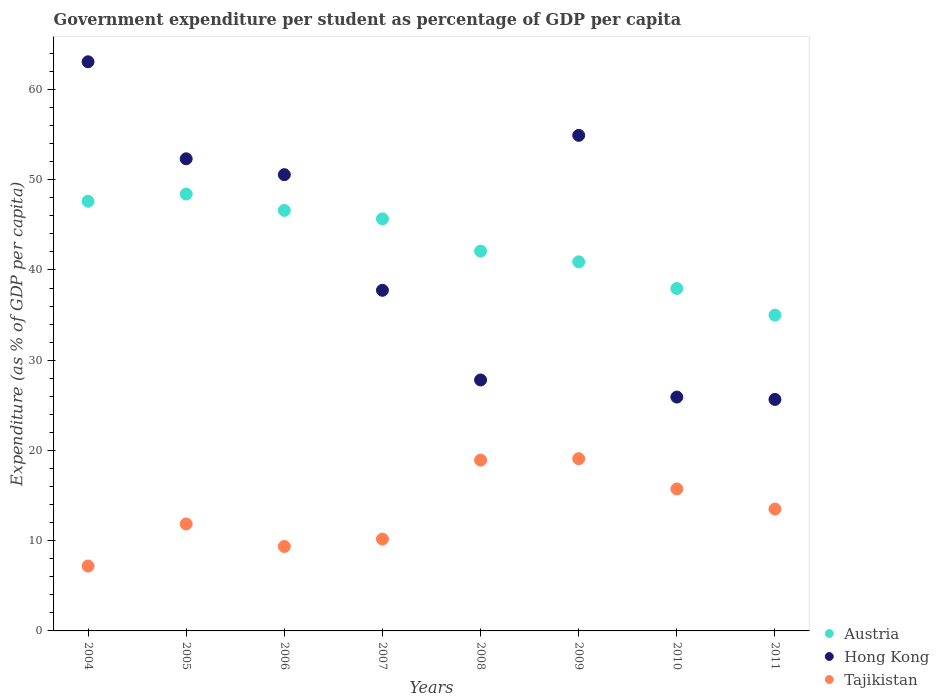What is the percentage of expenditure per student in Austria in 2006?
Your answer should be compact. 46.61. Across all years, what is the maximum percentage of expenditure per student in Austria?
Your answer should be compact. 48.42. Across all years, what is the minimum percentage of expenditure per student in Austria?
Keep it short and to the point. 35. In which year was the percentage of expenditure per student in Austria maximum?
Your response must be concise. 2005. What is the total percentage of expenditure per student in Tajikistan in the graph?
Make the answer very short. 105.85. What is the difference between the percentage of expenditure per student in Austria in 2006 and that in 2009?
Give a very brief answer. 5.7. What is the difference between the percentage of expenditure per student in Hong Kong in 2005 and the percentage of expenditure per student in Austria in 2008?
Provide a succinct answer. 10.23. What is the average percentage of expenditure per student in Tajikistan per year?
Offer a terse response. 13.23. In the year 2010, what is the difference between the percentage of expenditure per student in Hong Kong and percentage of expenditure per student in Tajikistan?
Provide a short and direct response. 10.18. In how many years, is the percentage of expenditure per student in Tajikistan greater than 46 %?
Offer a very short reply. 0. What is the ratio of the percentage of expenditure per student in Austria in 2006 to that in 2008?
Provide a succinct answer. 1.11. Is the percentage of expenditure per student in Tajikistan in 2006 less than that in 2011?
Provide a short and direct response. Yes. Is the difference between the percentage of expenditure per student in Hong Kong in 2007 and 2011 greater than the difference between the percentage of expenditure per student in Tajikistan in 2007 and 2011?
Ensure brevity in your answer.  Yes. What is the difference between the highest and the second highest percentage of expenditure per student in Tajikistan?
Offer a very short reply. 0.15. What is the difference between the highest and the lowest percentage of expenditure per student in Austria?
Provide a succinct answer. 13.42. In how many years, is the percentage of expenditure per student in Austria greater than the average percentage of expenditure per student in Austria taken over all years?
Your answer should be very brief. 4. Does the percentage of expenditure per student in Austria monotonically increase over the years?
Provide a short and direct response. No. Is the percentage of expenditure per student in Austria strictly greater than the percentage of expenditure per student in Tajikistan over the years?
Your answer should be compact. Yes. How many dotlines are there?
Your response must be concise. 3. Does the graph contain grids?
Your answer should be compact. No. How many legend labels are there?
Your answer should be compact. 3. How are the legend labels stacked?
Keep it short and to the point. Vertical. What is the title of the graph?
Keep it short and to the point. Government expenditure per student as percentage of GDP per capita. Does "Kenya" appear as one of the legend labels in the graph?
Give a very brief answer. No. What is the label or title of the X-axis?
Your answer should be very brief. Years. What is the label or title of the Y-axis?
Your answer should be very brief. Expenditure (as % of GDP per capita). What is the Expenditure (as % of GDP per capita) in Austria in 2004?
Give a very brief answer. 47.62. What is the Expenditure (as % of GDP per capita) of Hong Kong in 2004?
Ensure brevity in your answer.  63.07. What is the Expenditure (as % of GDP per capita) of Tajikistan in 2004?
Provide a short and direct response. 7.19. What is the Expenditure (as % of GDP per capita) of Austria in 2005?
Offer a very short reply. 48.42. What is the Expenditure (as % of GDP per capita) in Hong Kong in 2005?
Your response must be concise. 52.32. What is the Expenditure (as % of GDP per capita) in Tajikistan in 2005?
Keep it short and to the point. 11.86. What is the Expenditure (as % of GDP per capita) in Austria in 2006?
Provide a succinct answer. 46.61. What is the Expenditure (as % of GDP per capita) in Hong Kong in 2006?
Give a very brief answer. 50.56. What is the Expenditure (as % of GDP per capita) of Tajikistan in 2006?
Your answer should be compact. 9.36. What is the Expenditure (as % of GDP per capita) of Austria in 2007?
Your answer should be very brief. 45.67. What is the Expenditure (as % of GDP per capita) in Hong Kong in 2007?
Your answer should be compact. 37.75. What is the Expenditure (as % of GDP per capita) of Tajikistan in 2007?
Your answer should be compact. 10.18. What is the Expenditure (as % of GDP per capita) in Austria in 2008?
Make the answer very short. 42.09. What is the Expenditure (as % of GDP per capita) in Hong Kong in 2008?
Your answer should be very brief. 27.81. What is the Expenditure (as % of GDP per capita) of Tajikistan in 2008?
Your response must be concise. 18.93. What is the Expenditure (as % of GDP per capita) in Austria in 2009?
Your answer should be compact. 40.91. What is the Expenditure (as % of GDP per capita) of Hong Kong in 2009?
Ensure brevity in your answer.  54.92. What is the Expenditure (as % of GDP per capita) of Tajikistan in 2009?
Your response must be concise. 19.09. What is the Expenditure (as % of GDP per capita) in Austria in 2010?
Give a very brief answer. 37.95. What is the Expenditure (as % of GDP per capita) in Hong Kong in 2010?
Your answer should be very brief. 25.92. What is the Expenditure (as % of GDP per capita) in Tajikistan in 2010?
Your answer should be very brief. 15.73. What is the Expenditure (as % of GDP per capita) of Austria in 2011?
Your answer should be compact. 35. What is the Expenditure (as % of GDP per capita) in Hong Kong in 2011?
Your answer should be very brief. 25.65. What is the Expenditure (as % of GDP per capita) in Tajikistan in 2011?
Ensure brevity in your answer.  13.51. Across all years, what is the maximum Expenditure (as % of GDP per capita) of Austria?
Your answer should be very brief. 48.42. Across all years, what is the maximum Expenditure (as % of GDP per capita) in Hong Kong?
Provide a short and direct response. 63.07. Across all years, what is the maximum Expenditure (as % of GDP per capita) in Tajikistan?
Keep it short and to the point. 19.09. Across all years, what is the minimum Expenditure (as % of GDP per capita) of Austria?
Provide a short and direct response. 35. Across all years, what is the minimum Expenditure (as % of GDP per capita) of Hong Kong?
Keep it short and to the point. 25.65. Across all years, what is the minimum Expenditure (as % of GDP per capita) of Tajikistan?
Give a very brief answer. 7.19. What is the total Expenditure (as % of GDP per capita) in Austria in the graph?
Offer a very short reply. 344.25. What is the total Expenditure (as % of GDP per capita) of Hong Kong in the graph?
Keep it short and to the point. 338.02. What is the total Expenditure (as % of GDP per capita) in Tajikistan in the graph?
Provide a succinct answer. 105.85. What is the difference between the Expenditure (as % of GDP per capita) in Austria in 2004 and that in 2005?
Provide a succinct answer. -0.8. What is the difference between the Expenditure (as % of GDP per capita) in Hong Kong in 2004 and that in 2005?
Your answer should be very brief. 10.75. What is the difference between the Expenditure (as % of GDP per capita) in Tajikistan in 2004 and that in 2005?
Make the answer very short. -4.67. What is the difference between the Expenditure (as % of GDP per capita) in Austria in 2004 and that in 2006?
Offer a very short reply. 1.01. What is the difference between the Expenditure (as % of GDP per capita) in Hong Kong in 2004 and that in 2006?
Offer a terse response. 12.51. What is the difference between the Expenditure (as % of GDP per capita) of Tajikistan in 2004 and that in 2006?
Give a very brief answer. -2.17. What is the difference between the Expenditure (as % of GDP per capita) in Austria in 2004 and that in 2007?
Ensure brevity in your answer.  1.95. What is the difference between the Expenditure (as % of GDP per capita) of Hong Kong in 2004 and that in 2007?
Provide a short and direct response. 25.32. What is the difference between the Expenditure (as % of GDP per capita) of Tajikistan in 2004 and that in 2007?
Offer a very short reply. -2.98. What is the difference between the Expenditure (as % of GDP per capita) in Austria in 2004 and that in 2008?
Offer a very short reply. 5.53. What is the difference between the Expenditure (as % of GDP per capita) of Hong Kong in 2004 and that in 2008?
Your answer should be very brief. 35.26. What is the difference between the Expenditure (as % of GDP per capita) in Tajikistan in 2004 and that in 2008?
Your answer should be compact. -11.74. What is the difference between the Expenditure (as % of GDP per capita) in Austria in 2004 and that in 2009?
Your response must be concise. 6.71. What is the difference between the Expenditure (as % of GDP per capita) in Hong Kong in 2004 and that in 2009?
Keep it short and to the point. 8.15. What is the difference between the Expenditure (as % of GDP per capita) in Tajikistan in 2004 and that in 2009?
Offer a terse response. -11.89. What is the difference between the Expenditure (as % of GDP per capita) in Austria in 2004 and that in 2010?
Your response must be concise. 9.67. What is the difference between the Expenditure (as % of GDP per capita) of Hong Kong in 2004 and that in 2010?
Offer a terse response. 37.16. What is the difference between the Expenditure (as % of GDP per capita) of Tajikistan in 2004 and that in 2010?
Keep it short and to the point. -8.54. What is the difference between the Expenditure (as % of GDP per capita) in Austria in 2004 and that in 2011?
Offer a very short reply. 12.62. What is the difference between the Expenditure (as % of GDP per capita) of Hong Kong in 2004 and that in 2011?
Offer a very short reply. 37.42. What is the difference between the Expenditure (as % of GDP per capita) in Tajikistan in 2004 and that in 2011?
Make the answer very short. -6.31. What is the difference between the Expenditure (as % of GDP per capita) of Austria in 2005 and that in 2006?
Offer a very short reply. 1.81. What is the difference between the Expenditure (as % of GDP per capita) of Hong Kong in 2005 and that in 2006?
Make the answer very short. 1.76. What is the difference between the Expenditure (as % of GDP per capita) of Tajikistan in 2005 and that in 2006?
Your answer should be compact. 2.5. What is the difference between the Expenditure (as % of GDP per capita) of Austria in 2005 and that in 2007?
Provide a succinct answer. 2.75. What is the difference between the Expenditure (as % of GDP per capita) of Hong Kong in 2005 and that in 2007?
Make the answer very short. 14.57. What is the difference between the Expenditure (as % of GDP per capita) in Tajikistan in 2005 and that in 2007?
Ensure brevity in your answer.  1.68. What is the difference between the Expenditure (as % of GDP per capita) of Austria in 2005 and that in 2008?
Your answer should be compact. 6.33. What is the difference between the Expenditure (as % of GDP per capita) in Hong Kong in 2005 and that in 2008?
Give a very brief answer. 24.51. What is the difference between the Expenditure (as % of GDP per capita) in Tajikistan in 2005 and that in 2008?
Offer a very short reply. -7.07. What is the difference between the Expenditure (as % of GDP per capita) in Austria in 2005 and that in 2009?
Offer a terse response. 7.51. What is the difference between the Expenditure (as % of GDP per capita) in Hong Kong in 2005 and that in 2009?
Make the answer very short. -2.6. What is the difference between the Expenditure (as % of GDP per capita) of Tajikistan in 2005 and that in 2009?
Your response must be concise. -7.23. What is the difference between the Expenditure (as % of GDP per capita) of Austria in 2005 and that in 2010?
Ensure brevity in your answer.  10.47. What is the difference between the Expenditure (as % of GDP per capita) in Hong Kong in 2005 and that in 2010?
Provide a succinct answer. 26.4. What is the difference between the Expenditure (as % of GDP per capita) of Tajikistan in 2005 and that in 2010?
Keep it short and to the point. -3.88. What is the difference between the Expenditure (as % of GDP per capita) in Austria in 2005 and that in 2011?
Provide a short and direct response. 13.42. What is the difference between the Expenditure (as % of GDP per capita) of Hong Kong in 2005 and that in 2011?
Keep it short and to the point. 26.67. What is the difference between the Expenditure (as % of GDP per capita) of Tajikistan in 2005 and that in 2011?
Offer a very short reply. -1.65. What is the difference between the Expenditure (as % of GDP per capita) in Austria in 2006 and that in 2007?
Offer a very short reply. 0.94. What is the difference between the Expenditure (as % of GDP per capita) in Hong Kong in 2006 and that in 2007?
Provide a succinct answer. 12.81. What is the difference between the Expenditure (as % of GDP per capita) of Tajikistan in 2006 and that in 2007?
Offer a terse response. -0.82. What is the difference between the Expenditure (as % of GDP per capita) of Austria in 2006 and that in 2008?
Keep it short and to the point. 4.51. What is the difference between the Expenditure (as % of GDP per capita) of Hong Kong in 2006 and that in 2008?
Your answer should be very brief. 22.75. What is the difference between the Expenditure (as % of GDP per capita) of Tajikistan in 2006 and that in 2008?
Make the answer very short. -9.57. What is the difference between the Expenditure (as % of GDP per capita) in Austria in 2006 and that in 2009?
Provide a short and direct response. 5.7. What is the difference between the Expenditure (as % of GDP per capita) of Hong Kong in 2006 and that in 2009?
Ensure brevity in your answer.  -4.36. What is the difference between the Expenditure (as % of GDP per capita) of Tajikistan in 2006 and that in 2009?
Your response must be concise. -9.73. What is the difference between the Expenditure (as % of GDP per capita) of Austria in 2006 and that in 2010?
Your answer should be very brief. 8.66. What is the difference between the Expenditure (as % of GDP per capita) of Hong Kong in 2006 and that in 2010?
Your answer should be compact. 24.65. What is the difference between the Expenditure (as % of GDP per capita) of Tajikistan in 2006 and that in 2010?
Offer a terse response. -6.38. What is the difference between the Expenditure (as % of GDP per capita) in Austria in 2006 and that in 2011?
Provide a succinct answer. 11.61. What is the difference between the Expenditure (as % of GDP per capita) of Hong Kong in 2006 and that in 2011?
Offer a very short reply. 24.91. What is the difference between the Expenditure (as % of GDP per capita) of Tajikistan in 2006 and that in 2011?
Provide a short and direct response. -4.15. What is the difference between the Expenditure (as % of GDP per capita) in Austria in 2007 and that in 2008?
Make the answer very short. 3.58. What is the difference between the Expenditure (as % of GDP per capita) in Hong Kong in 2007 and that in 2008?
Offer a very short reply. 9.94. What is the difference between the Expenditure (as % of GDP per capita) in Tajikistan in 2007 and that in 2008?
Provide a short and direct response. -8.76. What is the difference between the Expenditure (as % of GDP per capita) of Austria in 2007 and that in 2009?
Your response must be concise. 4.76. What is the difference between the Expenditure (as % of GDP per capita) of Hong Kong in 2007 and that in 2009?
Give a very brief answer. -17.17. What is the difference between the Expenditure (as % of GDP per capita) in Tajikistan in 2007 and that in 2009?
Offer a terse response. -8.91. What is the difference between the Expenditure (as % of GDP per capita) in Austria in 2007 and that in 2010?
Offer a very short reply. 7.72. What is the difference between the Expenditure (as % of GDP per capita) in Hong Kong in 2007 and that in 2010?
Offer a terse response. 11.83. What is the difference between the Expenditure (as % of GDP per capita) of Tajikistan in 2007 and that in 2010?
Your answer should be very brief. -5.56. What is the difference between the Expenditure (as % of GDP per capita) of Austria in 2007 and that in 2011?
Give a very brief answer. 10.67. What is the difference between the Expenditure (as % of GDP per capita) of Hong Kong in 2007 and that in 2011?
Ensure brevity in your answer.  12.1. What is the difference between the Expenditure (as % of GDP per capita) in Tajikistan in 2007 and that in 2011?
Offer a very short reply. -3.33. What is the difference between the Expenditure (as % of GDP per capita) in Austria in 2008 and that in 2009?
Make the answer very short. 1.18. What is the difference between the Expenditure (as % of GDP per capita) in Hong Kong in 2008 and that in 2009?
Your response must be concise. -27.11. What is the difference between the Expenditure (as % of GDP per capita) of Tajikistan in 2008 and that in 2009?
Make the answer very short. -0.15. What is the difference between the Expenditure (as % of GDP per capita) in Austria in 2008 and that in 2010?
Your response must be concise. 4.14. What is the difference between the Expenditure (as % of GDP per capita) of Hong Kong in 2008 and that in 2010?
Ensure brevity in your answer.  1.9. What is the difference between the Expenditure (as % of GDP per capita) in Tajikistan in 2008 and that in 2010?
Keep it short and to the point. 3.2. What is the difference between the Expenditure (as % of GDP per capita) in Austria in 2008 and that in 2011?
Your answer should be very brief. 7.09. What is the difference between the Expenditure (as % of GDP per capita) of Hong Kong in 2008 and that in 2011?
Offer a terse response. 2.16. What is the difference between the Expenditure (as % of GDP per capita) in Tajikistan in 2008 and that in 2011?
Your answer should be compact. 5.43. What is the difference between the Expenditure (as % of GDP per capita) of Austria in 2009 and that in 2010?
Make the answer very short. 2.96. What is the difference between the Expenditure (as % of GDP per capita) in Hong Kong in 2009 and that in 2010?
Provide a succinct answer. 29. What is the difference between the Expenditure (as % of GDP per capita) of Tajikistan in 2009 and that in 2010?
Give a very brief answer. 3.35. What is the difference between the Expenditure (as % of GDP per capita) of Austria in 2009 and that in 2011?
Ensure brevity in your answer.  5.91. What is the difference between the Expenditure (as % of GDP per capita) in Hong Kong in 2009 and that in 2011?
Keep it short and to the point. 29.27. What is the difference between the Expenditure (as % of GDP per capita) in Tajikistan in 2009 and that in 2011?
Your answer should be compact. 5.58. What is the difference between the Expenditure (as % of GDP per capita) of Austria in 2010 and that in 2011?
Offer a very short reply. 2.95. What is the difference between the Expenditure (as % of GDP per capita) in Hong Kong in 2010 and that in 2011?
Ensure brevity in your answer.  0.26. What is the difference between the Expenditure (as % of GDP per capita) of Tajikistan in 2010 and that in 2011?
Your answer should be compact. 2.23. What is the difference between the Expenditure (as % of GDP per capita) of Austria in 2004 and the Expenditure (as % of GDP per capita) of Hong Kong in 2005?
Offer a very short reply. -4.7. What is the difference between the Expenditure (as % of GDP per capita) in Austria in 2004 and the Expenditure (as % of GDP per capita) in Tajikistan in 2005?
Keep it short and to the point. 35.76. What is the difference between the Expenditure (as % of GDP per capita) of Hong Kong in 2004 and the Expenditure (as % of GDP per capita) of Tajikistan in 2005?
Give a very brief answer. 51.22. What is the difference between the Expenditure (as % of GDP per capita) of Austria in 2004 and the Expenditure (as % of GDP per capita) of Hong Kong in 2006?
Your answer should be very brief. -2.94. What is the difference between the Expenditure (as % of GDP per capita) in Austria in 2004 and the Expenditure (as % of GDP per capita) in Tajikistan in 2006?
Your answer should be compact. 38.26. What is the difference between the Expenditure (as % of GDP per capita) of Hong Kong in 2004 and the Expenditure (as % of GDP per capita) of Tajikistan in 2006?
Give a very brief answer. 53.72. What is the difference between the Expenditure (as % of GDP per capita) in Austria in 2004 and the Expenditure (as % of GDP per capita) in Hong Kong in 2007?
Make the answer very short. 9.87. What is the difference between the Expenditure (as % of GDP per capita) of Austria in 2004 and the Expenditure (as % of GDP per capita) of Tajikistan in 2007?
Provide a succinct answer. 37.44. What is the difference between the Expenditure (as % of GDP per capita) in Hong Kong in 2004 and the Expenditure (as % of GDP per capita) in Tajikistan in 2007?
Ensure brevity in your answer.  52.9. What is the difference between the Expenditure (as % of GDP per capita) in Austria in 2004 and the Expenditure (as % of GDP per capita) in Hong Kong in 2008?
Give a very brief answer. 19.81. What is the difference between the Expenditure (as % of GDP per capita) in Austria in 2004 and the Expenditure (as % of GDP per capita) in Tajikistan in 2008?
Give a very brief answer. 28.69. What is the difference between the Expenditure (as % of GDP per capita) in Hong Kong in 2004 and the Expenditure (as % of GDP per capita) in Tajikistan in 2008?
Ensure brevity in your answer.  44.14. What is the difference between the Expenditure (as % of GDP per capita) in Austria in 2004 and the Expenditure (as % of GDP per capita) in Hong Kong in 2009?
Provide a short and direct response. -7.3. What is the difference between the Expenditure (as % of GDP per capita) of Austria in 2004 and the Expenditure (as % of GDP per capita) of Tajikistan in 2009?
Offer a terse response. 28.53. What is the difference between the Expenditure (as % of GDP per capita) of Hong Kong in 2004 and the Expenditure (as % of GDP per capita) of Tajikistan in 2009?
Your answer should be very brief. 43.99. What is the difference between the Expenditure (as % of GDP per capita) of Austria in 2004 and the Expenditure (as % of GDP per capita) of Hong Kong in 2010?
Offer a very short reply. 21.7. What is the difference between the Expenditure (as % of GDP per capita) in Austria in 2004 and the Expenditure (as % of GDP per capita) in Tajikistan in 2010?
Keep it short and to the point. 31.89. What is the difference between the Expenditure (as % of GDP per capita) of Hong Kong in 2004 and the Expenditure (as % of GDP per capita) of Tajikistan in 2010?
Give a very brief answer. 47.34. What is the difference between the Expenditure (as % of GDP per capita) in Austria in 2004 and the Expenditure (as % of GDP per capita) in Hong Kong in 2011?
Offer a terse response. 21.96. What is the difference between the Expenditure (as % of GDP per capita) of Austria in 2004 and the Expenditure (as % of GDP per capita) of Tajikistan in 2011?
Give a very brief answer. 34.11. What is the difference between the Expenditure (as % of GDP per capita) of Hong Kong in 2004 and the Expenditure (as % of GDP per capita) of Tajikistan in 2011?
Offer a terse response. 49.57. What is the difference between the Expenditure (as % of GDP per capita) of Austria in 2005 and the Expenditure (as % of GDP per capita) of Hong Kong in 2006?
Your answer should be very brief. -2.15. What is the difference between the Expenditure (as % of GDP per capita) of Austria in 2005 and the Expenditure (as % of GDP per capita) of Tajikistan in 2006?
Provide a short and direct response. 39.06. What is the difference between the Expenditure (as % of GDP per capita) in Hong Kong in 2005 and the Expenditure (as % of GDP per capita) in Tajikistan in 2006?
Offer a very short reply. 42.96. What is the difference between the Expenditure (as % of GDP per capita) of Austria in 2005 and the Expenditure (as % of GDP per capita) of Hong Kong in 2007?
Provide a short and direct response. 10.67. What is the difference between the Expenditure (as % of GDP per capita) of Austria in 2005 and the Expenditure (as % of GDP per capita) of Tajikistan in 2007?
Offer a terse response. 38.24. What is the difference between the Expenditure (as % of GDP per capita) of Hong Kong in 2005 and the Expenditure (as % of GDP per capita) of Tajikistan in 2007?
Keep it short and to the point. 42.15. What is the difference between the Expenditure (as % of GDP per capita) in Austria in 2005 and the Expenditure (as % of GDP per capita) in Hong Kong in 2008?
Offer a terse response. 20.6. What is the difference between the Expenditure (as % of GDP per capita) of Austria in 2005 and the Expenditure (as % of GDP per capita) of Tajikistan in 2008?
Make the answer very short. 29.48. What is the difference between the Expenditure (as % of GDP per capita) in Hong Kong in 2005 and the Expenditure (as % of GDP per capita) in Tajikistan in 2008?
Offer a terse response. 33.39. What is the difference between the Expenditure (as % of GDP per capita) in Austria in 2005 and the Expenditure (as % of GDP per capita) in Hong Kong in 2009?
Offer a terse response. -6.51. What is the difference between the Expenditure (as % of GDP per capita) in Austria in 2005 and the Expenditure (as % of GDP per capita) in Tajikistan in 2009?
Make the answer very short. 29.33. What is the difference between the Expenditure (as % of GDP per capita) of Hong Kong in 2005 and the Expenditure (as % of GDP per capita) of Tajikistan in 2009?
Offer a very short reply. 33.24. What is the difference between the Expenditure (as % of GDP per capita) of Austria in 2005 and the Expenditure (as % of GDP per capita) of Hong Kong in 2010?
Your response must be concise. 22.5. What is the difference between the Expenditure (as % of GDP per capita) of Austria in 2005 and the Expenditure (as % of GDP per capita) of Tajikistan in 2010?
Your answer should be very brief. 32.68. What is the difference between the Expenditure (as % of GDP per capita) of Hong Kong in 2005 and the Expenditure (as % of GDP per capita) of Tajikistan in 2010?
Your response must be concise. 36.59. What is the difference between the Expenditure (as % of GDP per capita) of Austria in 2005 and the Expenditure (as % of GDP per capita) of Hong Kong in 2011?
Provide a succinct answer. 22.76. What is the difference between the Expenditure (as % of GDP per capita) in Austria in 2005 and the Expenditure (as % of GDP per capita) in Tajikistan in 2011?
Give a very brief answer. 34.91. What is the difference between the Expenditure (as % of GDP per capita) of Hong Kong in 2005 and the Expenditure (as % of GDP per capita) of Tajikistan in 2011?
Offer a very short reply. 38.82. What is the difference between the Expenditure (as % of GDP per capita) in Austria in 2006 and the Expenditure (as % of GDP per capita) in Hong Kong in 2007?
Ensure brevity in your answer.  8.85. What is the difference between the Expenditure (as % of GDP per capita) of Austria in 2006 and the Expenditure (as % of GDP per capita) of Tajikistan in 2007?
Keep it short and to the point. 36.43. What is the difference between the Expenditure (as % of GDP per capita) in Hong Kong in 2006 and the Expenditure (as % of GDP per capita) in Tajikistan in 2007?
Your answer should be very brief. 40.39. What is the difference between the Expenditure (as % of GDP per capita) of Austria in 2006 and the Expenditure (as % of GDP per capita) of Hong Kong in 2008?
Offer a very short reply. 18.79. What is the difference between the Expenditure (as % of GDP per capita) of Austria in 2006 and the Expenditure (as % of GDP per capita) of Tajikistan in 2008?
Give a very brief answer. 27.67. What is the difference between the Expenditure (as % of GDP per capita) of Hong Kong in 2006 and the Expenditure (as % of GDP per capita) of Tajikistan in 2008?
Your answer should be very brief. 31.63. What is the difference between the Expenditure (as % of GDP per capita) of Austria in 2006 and the Expenditure (as % of GDP per capita) of Hong Kong in 2009?
Your answer should be very brief. -8.32. What is the difference between the Expenditure (as % of GDP per capita) in Austria in 2006 and the Expenditure (as % of GDP per capita) in Tajikistan in 2009?
Your answer should be very brief. 27.52. What is the difference between the Expenditure (as % of GDP per capita) of Hong Kong in 2006 and the Expenditure (as % of GDP per capita) of Tajikistan in 2009?
Offer a very short reply. 31.48. What is the difference between the Expenditure (as % of GDP per capita) in Austria in 2006 and the Expenditure (as % of GDP per capita) in Hong Kong in 2010?
Provide a succinct answer. 20.69. What is the difference between the Expenditure (as % of GDP per capita) of Austria in 2006 and the Expenditure (as % of GDP per capita) of Tajikistan in 2010?
Make the answer very short. 30.87. What is the difference between the Expenditure (as % of GDP per capita) of Hong Kong in 2006 and the Expenditure (as % of GDP per capita) of Tajikistan in 2010?
Offer a very short reply. 34.83. What is the difference between the Expenditure (as % of GDP per capita) in Austria in 2006 and the Expenditure (as % of GDP per capita) in Hong Kong in 2011?
Keep it short and to the point. 20.95. What is the difference between the Expenditure (as % of GDP per capita) in Austria in 2006 and the Expenditure (as % of GDP per capita) in Tajikistan in 2011?
Your response must be concise. 33.1. What is the difference between the Expenditure (as % of GDP per capita) in Hong Kong in 2006 and the Expenditure (as % of GDP per capita) in Tajikistan in 2011?
Give a very brief answer. 37.06. What is the difference between the Expenditure (as % of GDP per capita) of Austria in 2007 and the Expenditure (as % of GDP per capita) of Hong Kong in 2008?
Your answer should be compact. 17.85. What is the difference between the Expenditure (as % of GDP per capita) of Austria in 2007 and the Expenditure (as % of GDP per capita) of Tajikistan in 2008?
Your response must be concise. 26.73. What is the difference between the Expenditure (as % of GDP per capita) in Hong Kong in 2007 and the Expenditure (as % of GDP per capita) in Tajikistan in 2008?
Your answer should be compact. 18.82. What is the difference between the Expenditure (as % of GDP per capita) of Austria in 2007 and the Expenditure (as % of GDP per capita) of Hong Kong in 2009?
Offer a terse response. -9.25. What is the difference between the Expenditure (as % of GDP per capita) in Austria in 2007 and the Expenditure (as % of GDP per capita) in Tajikistan in 2009?
Your answer should be compact. 26.58. What is the difference between the Expenditure (as % of GDP per capita) in Hong Kong in 2007 and the Expenditure (as % of GDP per capita) in Tajikistan in 2009?
Your answer should be very brief. 18.66. What is the difference between the Expenditure (as % of GDP per capita) in Austria in 2007 and the Expenditure (as % of GDP per capita) in Hong Kong in 2010?
Give a very brief answer. 19.75. What is the difference between the Expenditure (as % of GDP per capita) of Austria in 2007 and the Expenditure (as % of GDP per capita) of Tajikistan in 2010?
Give a very brief answer. 29.93. What is the difference between the Expenditure (as % of GDP per capita) in Hong Kong in 2007 and the Expenditure (as % of GDP per capita) in Tajikistan in 2010?
Ensure brevity in your answer.  22.02. What is the difference between the Expenditure (as % of GDP per capita) of Austria in 2007 and the Expenditure (as % of GDP per capita) of Hong Kong in 2011?
Make the answer very short. 20.01. What is the difference between the Expenditure (as % of GDP per capita) in Austria in 2007 and the Expenditure (as % of GDP per capita) in Tajikistan in 2011?
Ensure brevity in your answer.  32.16. What is the difference between the Expenditure (as % of GDP per capita) of Hong Kong in 2007 and the Expenditure (as % of GDP per capita) of Tajikistan in 2011?
Make the answer very short. 24.24. What is the difference between the Expenditure (as % of GDP per capita) of Austria in 2008 and the Expenditure (as % of GDP per capita) of Hong Kong in 2009?
Your answer should be very brief. -12.83. What is the difference between the Expenditure (as % of GDP per capita) in Austria in 2008 and the Expenditure (as % of GDP per capita) in Tajikistan in 2009?
Offer a very short reply. 23. What is the difference between the Expenditure (as % of GDP per capita) in Hong Kong in 2008 and the Expenditure (as % of GDP per capita) in Tajikistan in 2009?
Your response must be concise. 8.73. What is the difference between the Expenditure (as % of GDP per capita) of Austria in 2008 and the Expenditure (as % of GDP per capita) of Hong Kong in 2010?
Offer a terse response. 16.17. What is the difference between the Expenditure (as % of GDP per capita) of Austria in 2008 and the Expenditure (as % of GDP per capita) of Tajikistan in 2010?
Your response must be concise. 26.36. What is the difference between the Expenditure (as % of GDP per capita) of Hong Kong in 2008 and the Expenditure (as % of GDP per capita) of Tajikistan in 2010?
Give a very brief answer. 12.08. What is the difference between the Expenditure (as % of GDP per capita) in Austria in 2008 and the Expenditure (as % of GDP per capita) in Hong Kong in 2011?
Your response must be concise. 16.44. What is the difference between the Expenditure (as % of GDP per capita) of Austria in 2008 and the Expenditure (as % of GDP per capita) of Tajikistan in 2011?
Your response must be concise. 28.58. What is the difference between the Expenditure (as % of GDP per capita) in Hong Kong in 2008 and the Expenditure (as % of GDP per capita) in Tajikistan in 2011?
Your answer should be compact. 14.31. What is the difference between the Expenditure (as % of GDP per capita) of Austria in 2009 and the Expenditure (as % of GDP per capita) of Hong Kong in 2010?
Offer a terse response. 14.99. What is the difference between the Expenditure (as % of GDP per capita) in Austria in 2009 and the Expenditure (as % of GDP per capita) in Tajikistan in 2010?
Offer a terse response. 25.17. What is the difference between the Expenditure (as % of GDP per capita) of Hong Kong in 2009 and the Expenditure (as % of GDP per capita) of Tajikistan in 2010?
Give a very brief answer. 39.19. What is the difference between the Expenditure (as % of GDP per capita) in Austria in 2009 and the Expenditure (as % of GDP per capita) in Hong Kong in 2011?
Your answer should be very brief. 15.25. What is the difference between the Expenditure (as % of GDP per capita) in Austria in 2009 and the Expenditure (as % of GDP per capita) in Tajikistan in 2011?
Give a very brief answer. 27.4. What is the difference between the Expenditure (as % of GDP per capita) in Hong Kong in 2009 and the Expenditure (as % of GDP per capita) in Tajikistan in 2011?
Offer a terse response. 41.41. What is the difference between the Expenditure (as % of GDP per capita) in Austria in 2010 and the Expenditure (as % of GDP per capita) in Hong Kong in 2011?
Offer a very short reply. 12.29. What is the difference between the Expenditure (as % of GDP per capita) of Austria in 2010 and the Expenditure (as % of GDP per capita) of Tajikistan in 2011?
Ensure brevity in your answer.  24.44. What is the difference between the Expenditure (as % of GDP per capita) in Hong Kong in 2010 and the Expenditure (as % of GDP per capita) in Tajikistan in 2011?
Provide a succinct answer. 12.41. What is the average Expenditure (as % of GDP per capita) in Austria per year?
Provide a short and direct response. 43.03. What is the average Expenditure (as % of GDP per capita) of Hong Kong per year?
Give a very brief answer. 42.25. What is the average Expenditure (as % of GDP per capita) in Tajikistan per year?
Your response must be concise. 13.23. In the year 2004, what is the difference between the Expenditure (as % of GDP per capita) in Austria and Expenditure (as % of GDP per capita) in Hong Kong?
Your answer should be very brief. -15.46. In the year 2004, what is the difference between the Expenditure (as % of GDP per capita) in Austria and Expenditure (as % of GDP per capita) in Tajikistan?
Make the answer very short. 40.43. In the year 2004, what is the difference between the Expenditure (as % of GDP per capita) in Hong Kong and Expenditure (as % of GDP per capita) in Tajikistan?
Offer a terse response. 55.88. In the year 2005, what is the difference between the Expenditure (as % of GDP per capita) in Austria and Expenditure (as % of GDP per capita) in Hong Kong?
Keep it short and to the point. -3.91. In the year 2005, what is the difference between the Expenditure (as % of GDP per capita) in Austria and Expenditure (as % of GDP per capita) in Tajikistan?
Offer a terse response. 36.56. In the year 2005, what is the difference between the Expenditure (as % of GDP per capita) in Hong Kong and Expenditure (as % of GDP per capita) in Tajikistan?
Offer a terse response. 40.46. In the year 2006, what is the difference between the Expenditure (as % of GDP per capita) of Austria and Expenditure (as % of GDP per capita) of Hong Kong?
Ensure brevity in your answer.  -3.96. In the year 2006, what is the difference between the Expenditure (as % of GDP per capita) in Austria and Expenditure (as % of GDP per capita) in Tajikistan?
Your answer should be very brief. 37.25. In the year 2006, what is the difference between the Expenditure (as % of GDP per capita) of Hong Kong and Expenditure (as % of GDP per capita) of Tajikistan?
Offer a terse response. 41.2. In the year 2007, what is the difference between the Expenditure (as % of GDP per capita) in Austria and Expenditure (as % of GDP per capita) in Hong Kong?
Give a very brief answer. 7.92. In the year 2007, what is the difference between the Expenditure (as % of GDP per capita) in Austria and Expenditure (as % of GDP per capita) in Tajikistan?
Ensure brevity in your answer.  35.49. In the year 2007, what is the difference between the Expenditure (as % of GDP per capita) in Hong Kong and Expenditure (as % of GDP per capita) in Tajikistan?
Your answer should be compact. 27.57. In the year 2008, what is the difference between the Expenditure (as % of GDP per capita) in Austria and Expenditure (as % of GDP per capita) in Hong Kong?
Offer a very short reply. 14.28. In the year 2008, what is the difference between the Expenditure (as % of GDP per capita) of Austria and Expenditure (as % of GDP per capita) of Tajikistan?
Your answer should be compact. 23.16. In the year 2008, what is the difference between the Expenditure (as % of GDP per capita) of Hong Kong and Expenditure (as % of GDP per capita) of Tajikistan?
Offer a terse response. 8.88. In the year 2009, what is the difference between the Expenditure (as % of GDP per capita) in Austria and Expenditure (as % of GDP per capita) in Hong Kong?
Make the answer very short. -14.01. In the year 2009, what is the difference between the Expenditure (as % of GDP per capita) in Austria and Expenditure (as % of GDP per capita) in Tajikistan?
Your answer should be very brief. 21.82. In the year 2009, what is the difference between the Expenditure (as % of GDP per capita) in Hong Kong and Expenditure (as % of GDP per capita) in Tajikistan?
Offer a very short reply. 35.83. In the year 2010, what is the difference between the Expenditure (as % of GDP per capita) of Austria and Expenditure (as % of GDP per capita) of Hong Kong?
Your response must be concise. 12.03. In the year 2010, what is the difference between the Expenditure (as % of GDP per capita) in Austria and Expenditure (as % of GDP per capita) in Tajikistan?
Your response must be concise. 22.21. In the year 2010, what is the difference between the Expenditure (as % of GDP per capita) of Hong Kong and Expenditure (as % of GDP per capita) of Tajikistan?
Your answer should be compact. 10.18. In the year 2011, what is the difference between the Expenditure (as % of GDP per capita) of Austria and Expenditure (as % of GDP per capita) of Hong Kong?
Make the answer very short. 9.34. In the year 2011, what is the difference between the Expenditure (as % of GDP per capita) of Austria and Expenditure (as % of GDP per capita) of Tajikistan?
Give a very brief answer. 21.49. In the year 2011, what is the difference between the Expenditure (as % of GDP per capita) in Hong Kong and Expenditure (as % of GDP per capita) in Tajikistan?
Your answer should be compact. 12.15. What is the ratio of the Expenditure (as % of GDP per capita) in Austria in 2004 to that in 2005?
Your answer should be compact. 0.98. What is the ratio of the Expenditure (as % of GDP per capita) of Hong Kong in 2004 to that in 2005?
Keep it short and to the point. 1.21. What is the ratio of the Expenditure (as % of GDP per capita) of Tajikistan in 2004 to that in 2005?
Provide a short and direct response. 0.61. What is the ratio of the Expenditure (as % of GDP per capita) in Austria in 2004 to that in 2006?
Keep it short and to the point. 1.02. What is the ratio of the Expenditure (as % of GDP per capita) in Hong Kong in 2004 to that in 2006?
Give a very brief answer. 1.25. What is the ratio of the Expenditure (as % of GDP per capita) in Tajikistan in 2004 to that in 2006?
Give a very brief answer. 0.77. What is the ratio of the Expenditure (as % of GDP per capita) of Austria in 2004 to that in 2007?
Offer a very short reply. 1.04. What is the ratio of the Expenditure (as % of GDP per capita) of Hong Kong in 2004 to that in 2007?
Make the answer very short. 1.67. What is the ratio of the Expenditure (as % of GDP per capita) of Tajikistan in 2004 to that in 2007?
Your response must be concise. 0.71. What is the ratio of the Expenditure (as % of GDP per capita) of Austria in 2004 to that in 2008?
Keep it short and to the point. 1.13. What is the ratio of the Expenditure (as % of GDP per capita) in Hong Kong in 2004 to that in 2008?
Offer a very short reply. 2.27. What is the ratio of the Expenditure (as % of GDP per capita) of Tajikistan in 2004 to that in 2008?
Keep it short and to the point. 0.38. What is the ratio of the Expenditure (as % of GDP per capita) of Austria in 2004 to that in 2009?
Your response must be concise. 1.16. What is the ratio of the Expenditure (as % of GDP per capita) in Hong Kong in 2004 to that in 2009?
Your answer should be compact. 1.15. What is the ratio of the Expenditure (as % of GDP per capita) of Tajikistan in 2004 to that in 2009?
Ensure brevity in your answer.  0.38. What is the ratio of the Expenditure (as % of GDP per capita) of Austria in 2004 to that in 2010?
Your response must be concise. 1.25. What is the ratio of the Expenditure (as % of GDP per capita) of Hong Kong in 2004 to that in 2010?
Ensure brevity in your answer.  2.43. What is the ratio of the Expenditure (as % of GDP per capita) in Tajikistan in 2004 to that in 2010?
Give a very brief answer. 0.46. What is the ratio of the Expenditure (as % of GDP per capita) of Austria in 2004 to that in 2011?
Offer a terse response. 1.36. What is the ratio of the Expenditure (as % of GDP per capita) in Hong Kong in 2004 to that in 2011?
Provide a succinct answer. 2.46. What is the ratio of the Expenditure (as % of GDP per capita) of Tajikistan in 2004 to that in 2011?
Keep it short and to the point. 0.53. What is the ratio of the Expenditure (as % of GDP per capita) in Austria in 2005 to that in 2006?
Offer a terse response. 1.04. What is the ratio of the Expenditure (as % of GDP per capita) of Hong Kong in 2005 to that in 2006?
Make the answer very short. 1.03. What is the ratio of the Expenditure (as % of GDP per capita) of Tajikistan in 2005 to that in 2006?
Provide a succinct answer. 1.27. What is the ratio of the Expenditure (as % of GDP per capita) of Austria in 2005 to that in 2007?
Offer a very short reply. 1.06. What is the ratio of the Expenditure (as % of GDP per capita) in Hong Kong in 2005 to that in 2007?
Keep it short and to the point. 1.39. What is the ratio of the Expenditure (as % of GDP per capita) of Tajikistan in 2005 to that in 2007?
Offer a very short reply. 1.17. What is the ratio of the Expenditure (as % of GDP per capita) of Austria in 2005 to that in 2008?
Give a very brief answer. 1.15. What is the ratio of the Expenditure (as % of GDP per capita) of Hong Kong in 2005 to that in 2008?
Your response must be concise. 1.88. What is the ratio of the Expenditure (as % of GDP per capita) of Tajikistan in 2005 to that in 2008?
Your answer should be compact. 0.63. What is the ratio of the Expenditure (as % of GDP per capita) of Austria in 2005 to that in 2009?
Keep it short and to the point. 1.18. What is the ratio of the Expenditure (as % of GDP per capita) in Hong Kong in 2005 to that in 2009?
Provide a succinct answer. 0.95. What is the ratio of the Expenditure (as % of GDP per capita) of Tajikistan in 2005 to that in 2009?
Your response must be concise. 0.62. What is the ratio of the Expenditure (as % of GDP per capita) of Austria in 2005 to that in 2010?
Keep it short and to the point. 1.28. What is the ratio of the Expenditure (as % of GDP per capita) in Hong Kong in 2005 to that in 2010?
Keep it short and to the point. 2.02. What is the ratio of the Expenditure (as % of GDP per capita) in Tajikistan in 2005 to that in 2010?
Provide a short and direct response. 0.75. What is the ratio of the Expenditure (as % of GDP per capita) of Austria in 2005 to that in 2011?
Provide a succinct answer. 1.38. What is the ratio of the Expenditure (as % of GDP per capita) of Hong Kong in 2005 to that in 2011?
Make the answer very short. 2.04. What is the ratio of the Expenditure (as % of GDP per capita) of Tajikistan in 2005 to that in 2011?
Your answer should be compact. 0.88. What is the ratio of the Expenditure (as % of GDP per capita) in Austria in 2006 to that in 2007?
Make the answer very short. 1.02. What is the ratio of the Expenditure (as % of GDP per capita) in Hong Kong in 2006 to that in 2007?
Keep it short and to the point. 1.34. What is the ratio of the Expenditure (as % of GDP per capita) in Tajikistan in 2006 to that in 2007?
Keep it short and to the point. 0.92. What is the ratio of the Expenditure (as % of GDP per capita) of Austria in 2006 to that in 2008?
Offer a terse response. 1.11. What is the ratio of the Expenditure (as % of GDP per capita) in Hong Kong in 2006 to that in 2008?
Provide a succinct answer. 1.82. What is the ratio of the Expenditure (as % of GDP per capita) of Tajikistan in 2006 to that in 2008?
Your answer should be compact. 0.49. What is the ratio of the Expenditure (as % of GDP per capita) in Austria in 2006 to that in 2009?
Provide a short and direct response. 1.14. What is the ratio of the Expenditure (as % of GDP per capita) of Hong Kong in 2006 to that in 2009?
Ensure brevity in your answer.  0.92. What is the ratio of the Expenditure (as % of GDP per capita) of Tajikistan in 2006 to that in 2009?
Ensure brevity in your answer.  0.49. What is the ratio of the Expenditure (as % of GDP per capita) of Austria in 2006 to that in 2010?
Keep it short and to the point. 1.23. What is the ratio of the Expenditure (as % of GDP per capita) of Hong Kong in 2006 to that in 2010?
Give a very brief answer. 1.95. What is the ratio of the Expenditure (as % of GDP per capita) of Tajikistan in 2006 to that in 2010?
Your answer should be very brief. 0.59. What is the ratio of the Expenditure (as % of GDP per capita) of Austria in 2006 to that in 2011?
Give a very brief answer. 1.33. What is the ratio of the Expenditure (as % of GDP per capita) of Hong Kong in 2006 to that in 2011?
Give a very brief answer. 1.97. What is the ratio of the Expenditure (as % of GDP per capita) in Tajikistan in 2006 to that in 2011?
Offer a very short reply. 0.69. What is the ratio of the Expenditure (as % of GDP per capita) in Austria in 2007 to that in 2008?
Keep it short and to the point. 1.08. What is the ratio of the Expenditure (as % of GDP per capita) of Hong Kong in 2007 to that in 2008?
Your response must be concise. 1.36. What is the ratio of the Expenditure (as % of GDP per capita) in Tajikistan in 2007 to that in 2008?
Make the answer very short. 0.54. What is the ratio of the Expenditure (as % of GDP per capita) of Austria in 2007 to that in 2009?
Make the answer very short. 1.12. What is the ratio of the Expenditure (as % of GDP per capita) in Hong Kong in 2007 to that in 2009?
Your answer should be compact. 0.69. What is the ratio of the Expenditure (as % of GDP per capita) of Tajikistan in 2007 to that in 2009?
Offer a very short reply. 0.53. What is the ratio of the Expenditure (as % of GDP per capita) of Austria in 2007 to that in 2010?
Your answer should be compact. 1.2. What is the ratio of the Expenditure (as % of GDP per capita) in Hong Kong in 2007 to that in 2010?
Your response must be concise. 1.46. What is the ratio of the Expenditure (as % of GDP per capita) of Tajikistan in 2007 to that in 2010?
Provide a succinct answer. 0.65. What is the ratio of the Expenditure (as % of GDP per capita) of Austria in 2007 to that in 2011?
Make the answer very short. 1.3. What is the ratio of the Expenditure (as % of GDP per capita) in Hong Kong in 2007 to that in 2011?
Give a very brief answer. 1.47. What is the ratio of the Expenditure (as % of GDP per capita) in Tajikistan in 2007 to that in 2011?
Your answer should be very brief. 0.75. What is the ratio of the Expenditure (as % of GDP per capita) in Austria in 2008 to that in 2009?
Make the answer very short. 1.03. What is the ratio of the Expenditure (as % of GDP per capita) of Hong Kong in 2008 to that in 2009?
Your answer should be very brief. 0.51. What is the ratio of the Expenditure (as % of GDP per capita) of Austria in 2008 to that in 2010?
Provide a short and direct response. 1.11. What is the ratio of the Expenditure (as % of GDP per capita) in Hong Kong in 2008 to that in 2010?
Your answer should be very brief. 1.07. What is the ratio of the Expenditure (as % of GDP per capita) of Tajikistan in 2008 to that in 2010?
Your answer should be very brief. 1.2. What is the ratio of the Expenditure (as % of GDP per capita) of Austria in 2008 to that in 2011?
Your response must be concise. 1.2. What is the ratio of the Expenditure (as % of GDP per capita) of Hong Kong in 2008 to that in 2011?
Make the answer very short. 1.08. What is the ratio of the Expenditure (as % of GDP per capita) of Tajikistan in 2008 to that in 2011?
Give a very brief answer. 1.4. What is the ratio of the Expenditure (as % of GDP per capita) in Austria in 2009 to that in 2010?
Give a very brief answer. 1.08. What is the ratio of the Expenditure (as % of GDP per capita) in Hong Kong in 2009 to that in 2010?
Your response must be concise. 2.12. What is the ratio of the Expenditure (as % of GDP per capita) of Tajikistan in 2009 to that in 2010?
Make the answer very short. 1.21. What is the ratio of the Expenditure (as % of GDP per capita) in Austria in 2009 to that in 2011?
Your answer should be very brief. 1.17. What is the ratio of the Expenditure (as % of GDP per capita) of Hong Kong in 2009 to that in 2011?
Ensure brevity in your answer.  2.14. What is the ratio of the Expenditure (as % of GDP per capita) of Tajikistan in 2009 to that in 2011?
Make the answer very short. 1.41. What is the ratio of the Expenditure (as % of GDP per capita) in Austria in 2010 to that in 2011?
Provide a succinct answer. 1.08. What is the ratio of the Expenditure (as % of GDP per capita) in Hong Kong in 2010 to that in 2011?
Your answer should be compact. 1.01. What is the ratio of the Expenditure (as % of GDP per capita) in Tajikistan in 2010 to that in 2011?
Keep it short and to the point. 1.16. What is the difference between the highest and the second highest Expenditure (as % of GDP per capita) of Austria?
Offer a very short reply. 0.8. What is the difference between the highest and the second highest Expenditure (as % of GDP per capita) of Hong Kong?
Your answer should be very brief. 8.15. What is the difference between the highest and the second highest Expenditure (as % of GDP per capita) of Tajikistan?
Your response must be concise. 0.15. What is the difference between the highest and the lowest Expenditure (as % of GDP per capita) in Austria?
Offer a very short reply. 13.42. What is the difference between the highest and the lowest Expenditure (as % of GDP per capita) of Hong Kong?
Provide a short and direct response. 37.42. What is the difference between the highest and the lowest Expenditure (as % of GDP per capita) of Tajikistan?
Your answer should be very brief. 11.89. 